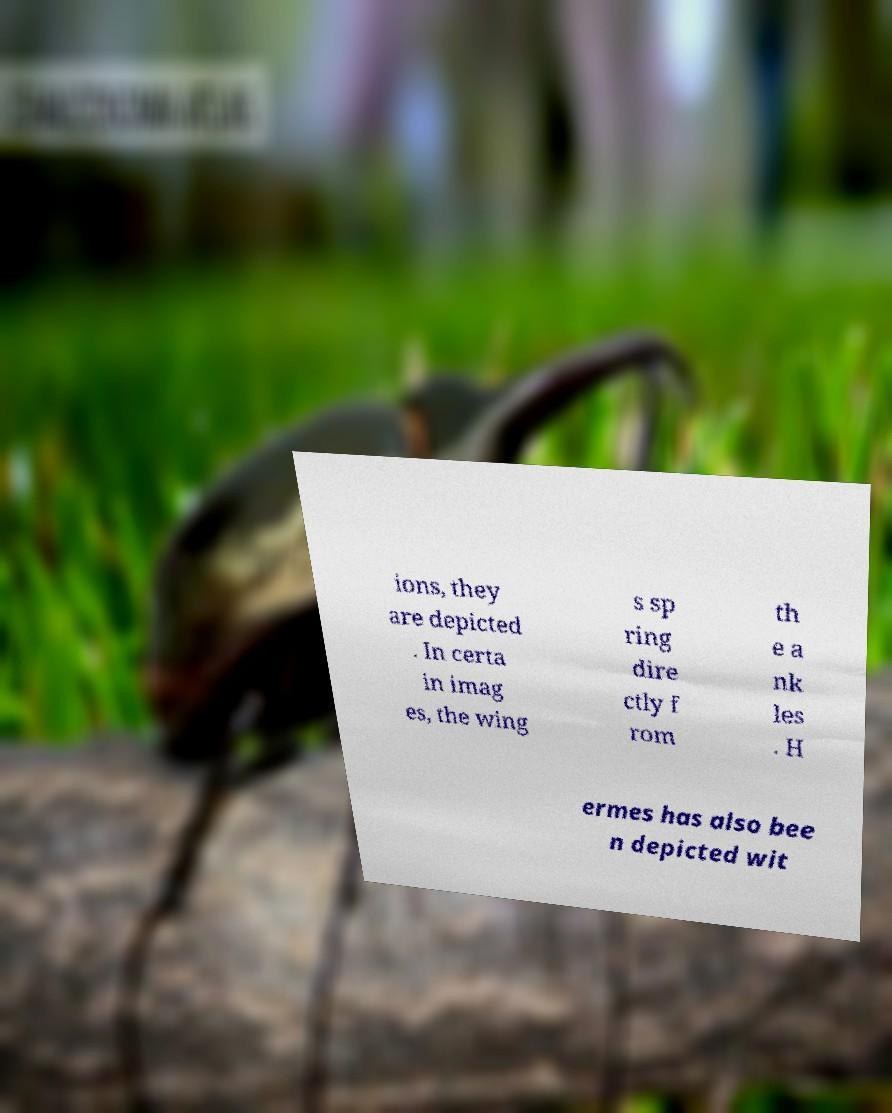There's text embedded in this image that I need extracted. Can you transcribe it verbatim? ions, they are depicted . In certa in imag es, the wing s sp ring dire ctly f rom th e a nk les . H ermes has also bee n depicted wit 